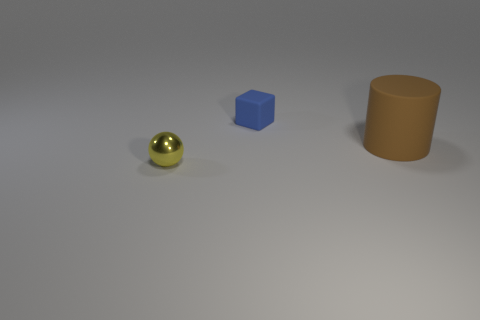Add 3 big rubber balls. How many objects exist? 6 Subtract all balls. How many objects are left? 2 Subtract 0 green spheres. How many objects are left? 3 Subtract all green matte spheres. Subtract all brown cylinders. How many objects are left? 2 Add 1 brown things. How many brown things are left? 2 Add 3 matte things. How many matte things exist? 5 